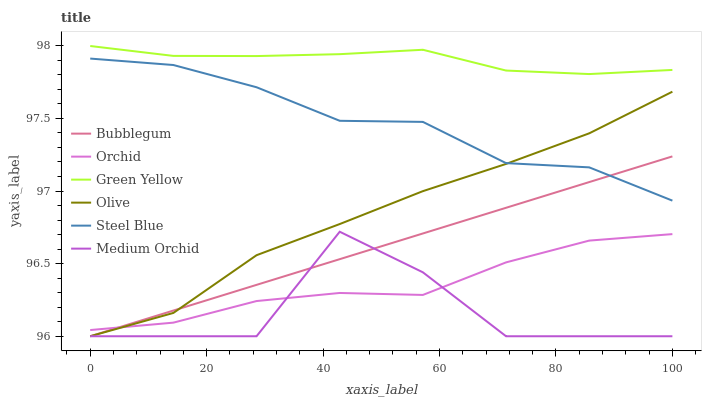Does Medium Orchid have the minimum area under the curve?
Answer yes or no. Yes. Does Green Yellow have the maximum area under the curve?
Answer yes or no. Yes. Does Steel Blue have the minimum area under the curve?
Answer yes or no. No. Does Steel Blue have the maximum area under the curve?
Answer yes or no. No. Is Bubblegum the smoothest?
Answer yes or no. Yes. Is Medium Orchid the roughest?
Answer yes or no. Yes. Is Steel Blue the smoothest?
Answer yes or no. No. Is Steel Blue the roughest?
Answer yes or no. No. Does Medium Orchid have the lowest value?
Answer yes or no. Yes. Does Steel Blue have the lowest value?
Answer yes or no. No. Does Green Yellow have the highest value?
Answer yes or no. Yes. Does Steel Blue have the highest value?
Answer yes or no. No. Is Medium Orchid less than Green Yellow?
Answer yes or no. Yes. Is Steel Blue greater than Medium Orchid?
Answer yes or no. Yes. Does Bubblegum intersect Steel Blue?
Answer yes or no. Yes. Is Bubblegum less than Steel Blue?
Answer yes or no. No. Is Bubblegum greater than Steel Blue?
Answer yes or no. No. Does Medium Orchid intersect Green Yellow?
Answer yes or no. No. 